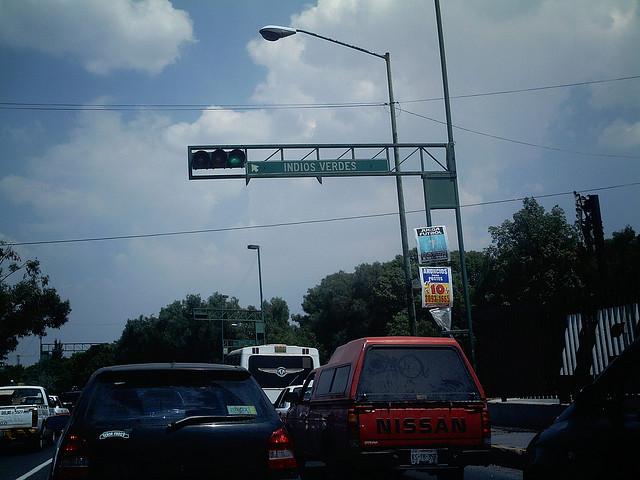Is the traffic light facing away?
Give a very brief answer. No. Are these cars moving through the light or stopped at it?
Keep it brief. Moving. Is that an old car?
Concise answer only. Yes. Which truck has heavy front protection?
Write a very short answer. Nissan. Is there any pine trees?
Quick response, please. No. What words are written on the green sign?
Write a very short answer. Indios verdes. How many police vehicles can be seen?
Short answer required. 0. Does the driver have their foot on the brakes?
Write a very short answer. Yes. What street is this?
Write a very short answer. Indios verdes. Is it going to rain?
Write a very short answer. No. What type of truck is on the street?
Give a very brief answer. Nissan. Is this picture taken at day time?
Quick response, please. Yes. What is the name of this street?
Quick response, please. Indios verdes. What street name is on the sign?
Quick response, please. Indios verdes. What image is in the circle on the black car?
Quick response, please. Sticker. What color is the traffic light?
Concise answer only. Green. How many cars are parked and visible?
Give a very brief answer. 5. What is on the sign?
Short answer required. Indios verdes. What is the sign on the right for?
Concise answer only. Indios verdes. What is the name of the road?
Answer briefly. Indios verdes. What letters are on the truck?
Short answer required. Nissan. How can you tell this photo is not from America?
Answer briefly. Sign mentions location in mexico. Is it obvious the car is supposed to be blue?
Give a very brief answer. No. Are the street lights on?
Quick response, please. No. What would happen if this car were to speed forward?
Short answer required. Crash. Which way do you have to go?
Give a very brief answer. Straight. What brand car is this?
Concise answer only. Nissan. Are all these cars parked?
Answer briefly. No. Is traffic congested?
Give a very brief answer. Yes. In what city is this scene from?
Answer briefly. Boston. Is there a man on the back of the truck?
Answer briefly. No. Do these vehicles have drivers?
Keep it brief. Yes. Should the car in the background on the left stop or go now?
Concise answer only. Go. What is written on the red SUV?
Concise answer only. Nissan. Is it daytime?
Short answer required. Yes. What cars can you see?
Write a very short answer. 5. What make is this truck?
Be succinct. Nissan. 